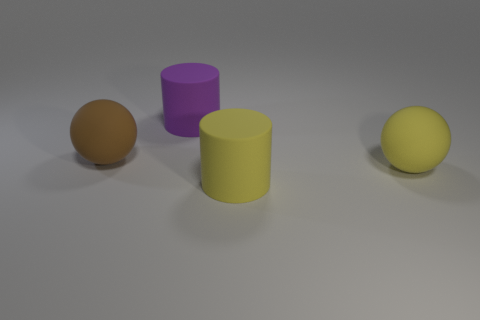What mood or atmosphere does this image evoke? The image exudes a calm and minimalist aura, derived from the soft lighting and neutral backdrop. The simplicity of the scene conveys a tranquil and uncluttered space. Could you infer anything about the purpose of this image? Given its simplicity and focus on forms and colors, the image might be used for educational purposes, such as teaching about shapes, colors, and perspective, or it could be a render testing object lighting in 3D modeling software. 